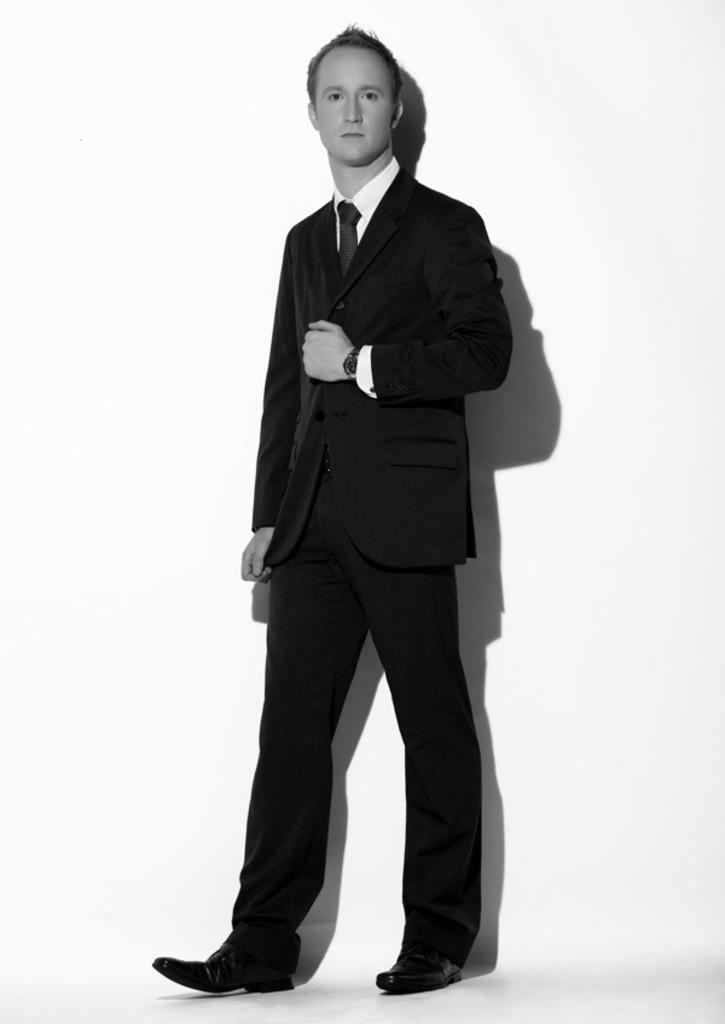What is the color scheme of the image? The image is black and white. Who is present in the image? There is a man in the image. What is the man wearing? The man is wearing a suit. What is the man doing in the image? The man is standing and giving a pose for the picture. What color is the background of the image? The background of the image is white. What type of tin can be seen in the man's hand in the image? There is no tin present in the man's hand or in the image. Is the man in the image advertising a product? The image does not provide any information about the man advertising a product. 